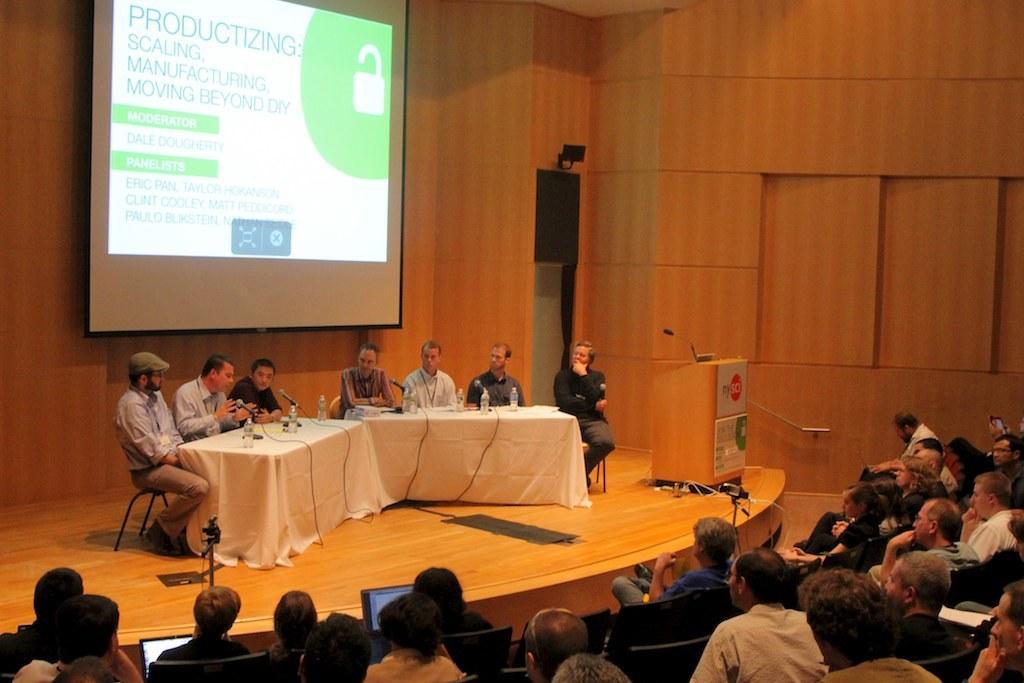In one or two sentences, can you explain what this image depicts? In this image I can see a stage , on the stage I can see a table , on the table I can see clothes, mikes and bottles and in front of table I can see there are few persons sitting on chairs and on the stage I can see a podium visible in the middle and I can see there are crowd of people visible at the bottom sitting on the chair at the top I can see the wall and I can see screen attached to the wall in the middle. 